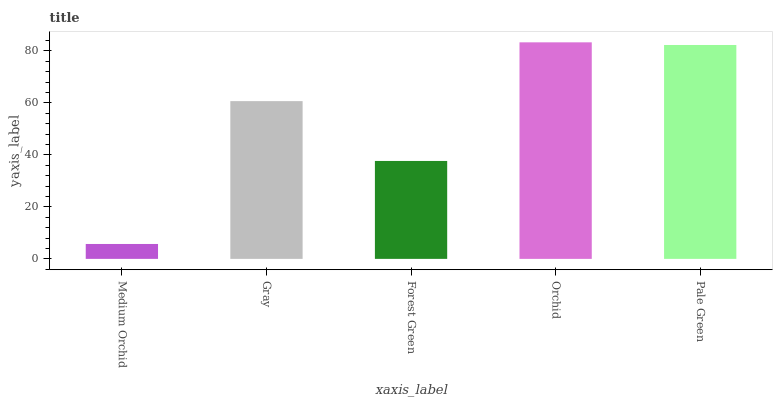Is Medium Orchid the minimum?
Answer yes or no. Yes. Is Orchid the maximum?
Answer yes or no. Yes. Is Gray the minimum?
Answer yes or no. No. Is Gray the maximum?
Answer yes or no. No. Is Gray greater than Medium Orchid?
Answer yes or no. Yes. Is Medium Orchid less than Gray?
Answer yes or no. Yes. Is Medium Orchid greater than Gray?
Answer yes or no. No. Is Gray less than Medium Orchid?
Answer yes or no. No. Is Gray the high median?
Answer yes or no. Yes. Is Gray the low median?
Answer yes or no. Yes. Is Medium Orchid the high median?
Answer yes or no. No. Is Orchid the low median?
Answer yes or no. No. 